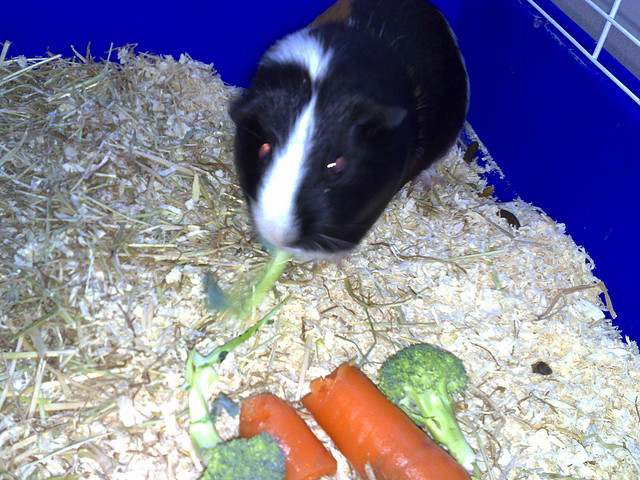How many broccolis can you see? 2 